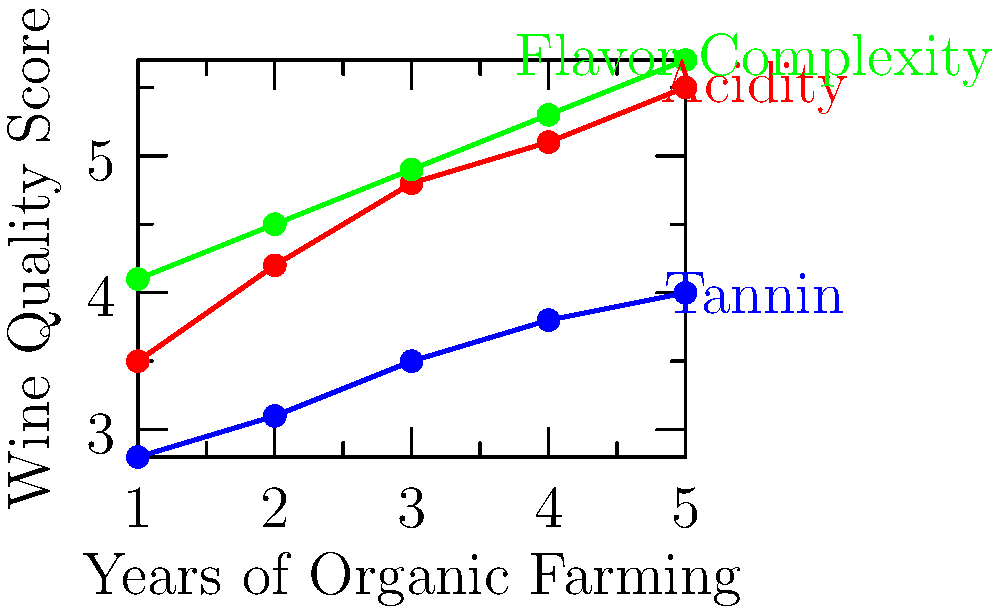Based on the multi-variable scatter plot showing the relationship between years of organic farming and various wine quality indicators for your Frascati wine, which quality attribute shows the most significant improvement over time? To determine which quality attribute shows the most significant improvement over time, we need to analyze the slope of each line in the scatter plot:

1. Red line (Acidity):
   - Starts at about 3.5 and ends at 5.5
   - Total increase: 5.5 - 3.5 = 2.0
   - Rate of increase: 2.0 / 4 years = 0.5 per year

2. Blue line (Tannin):
   - Starts at about 2.8 and ends at 4.0
   - Total increase: 4.0 - 2.8 = 1.2
   - Rate of increase: 1.2 / 4 years = 0.3 per year

3. Green line (Flavor Complexity):
   - Starts at about 4.1 and ends at 5.7
   - Total increase: 5.7 - 4.1 = 1.6
   - Rate of increase: 1.6 / 4 years = 0.4 per year

The attribute with the steepest slope and highest rate of increase shows the most significant improvement over time. In this case, it's Acidity with a rate of 0.5 per year.
Answer: Acidity 